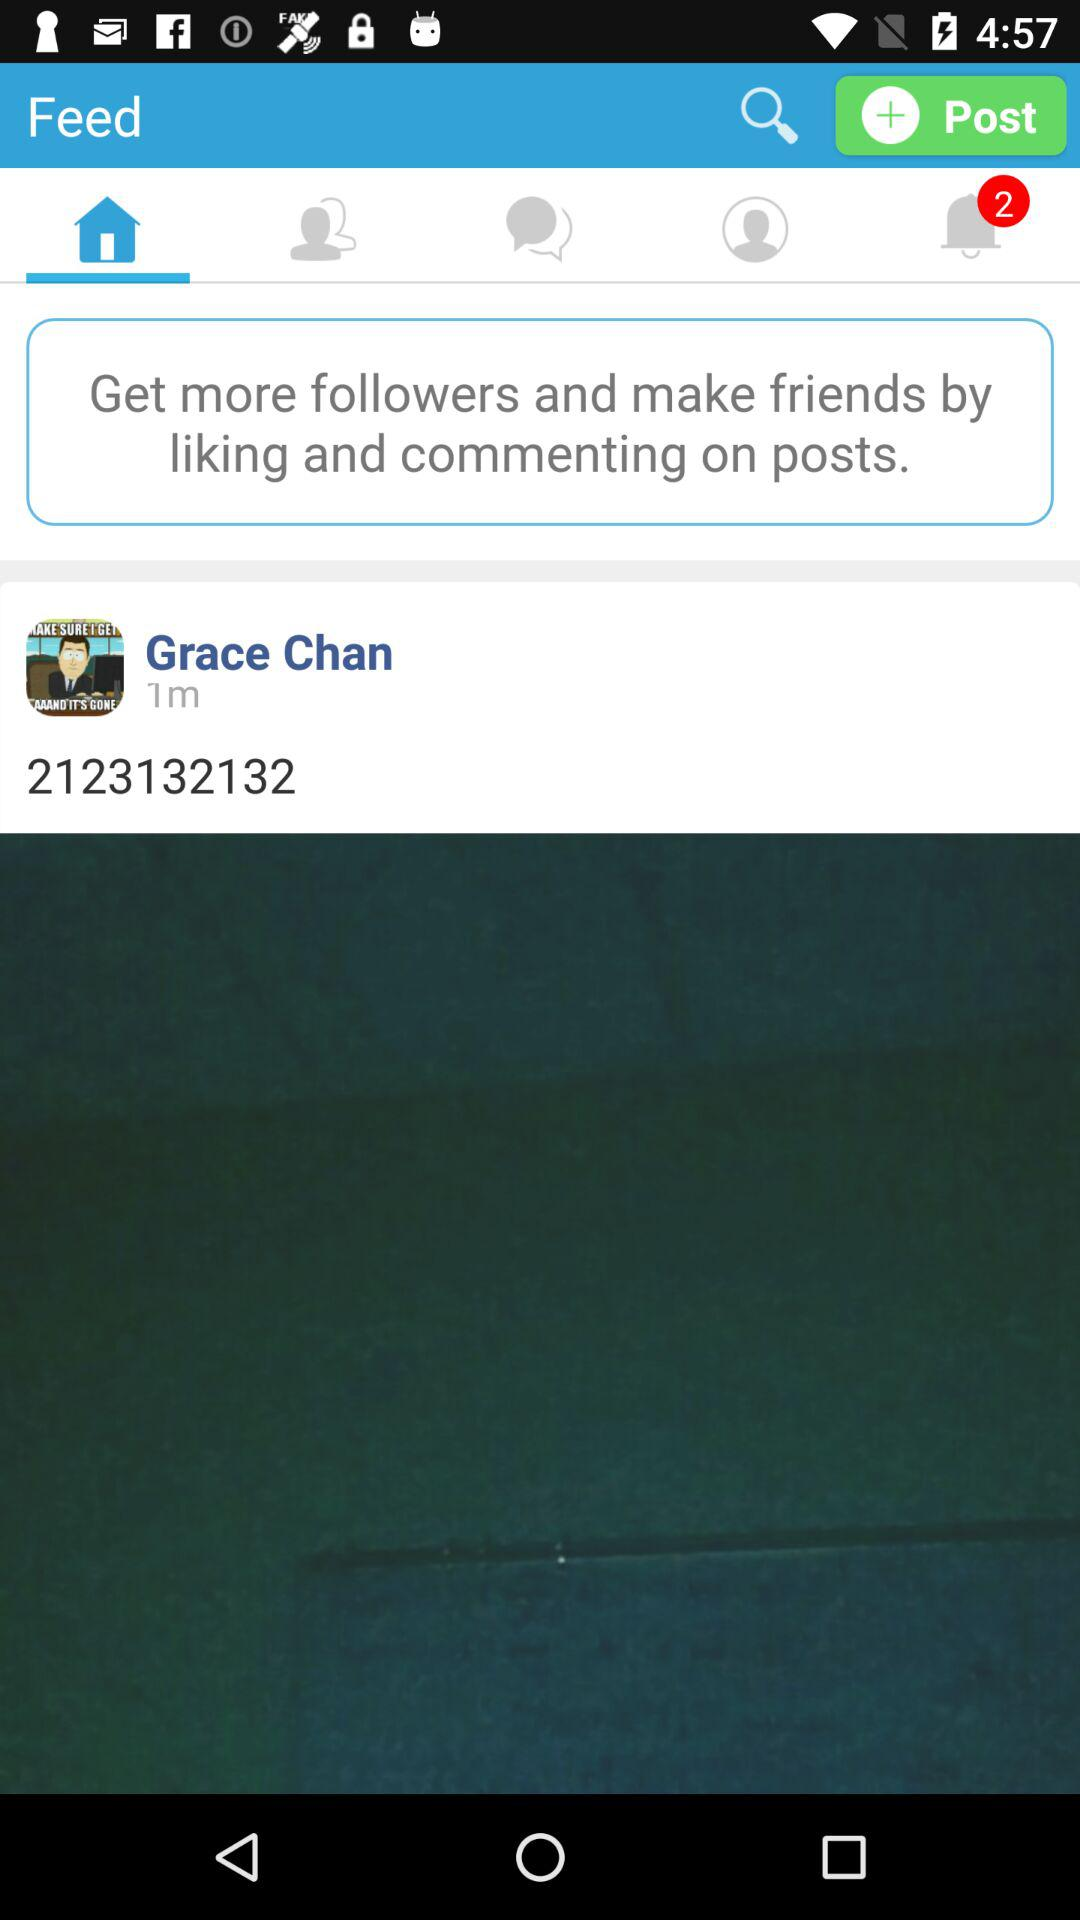What's the number of notifications? The number of notifications is 2. 